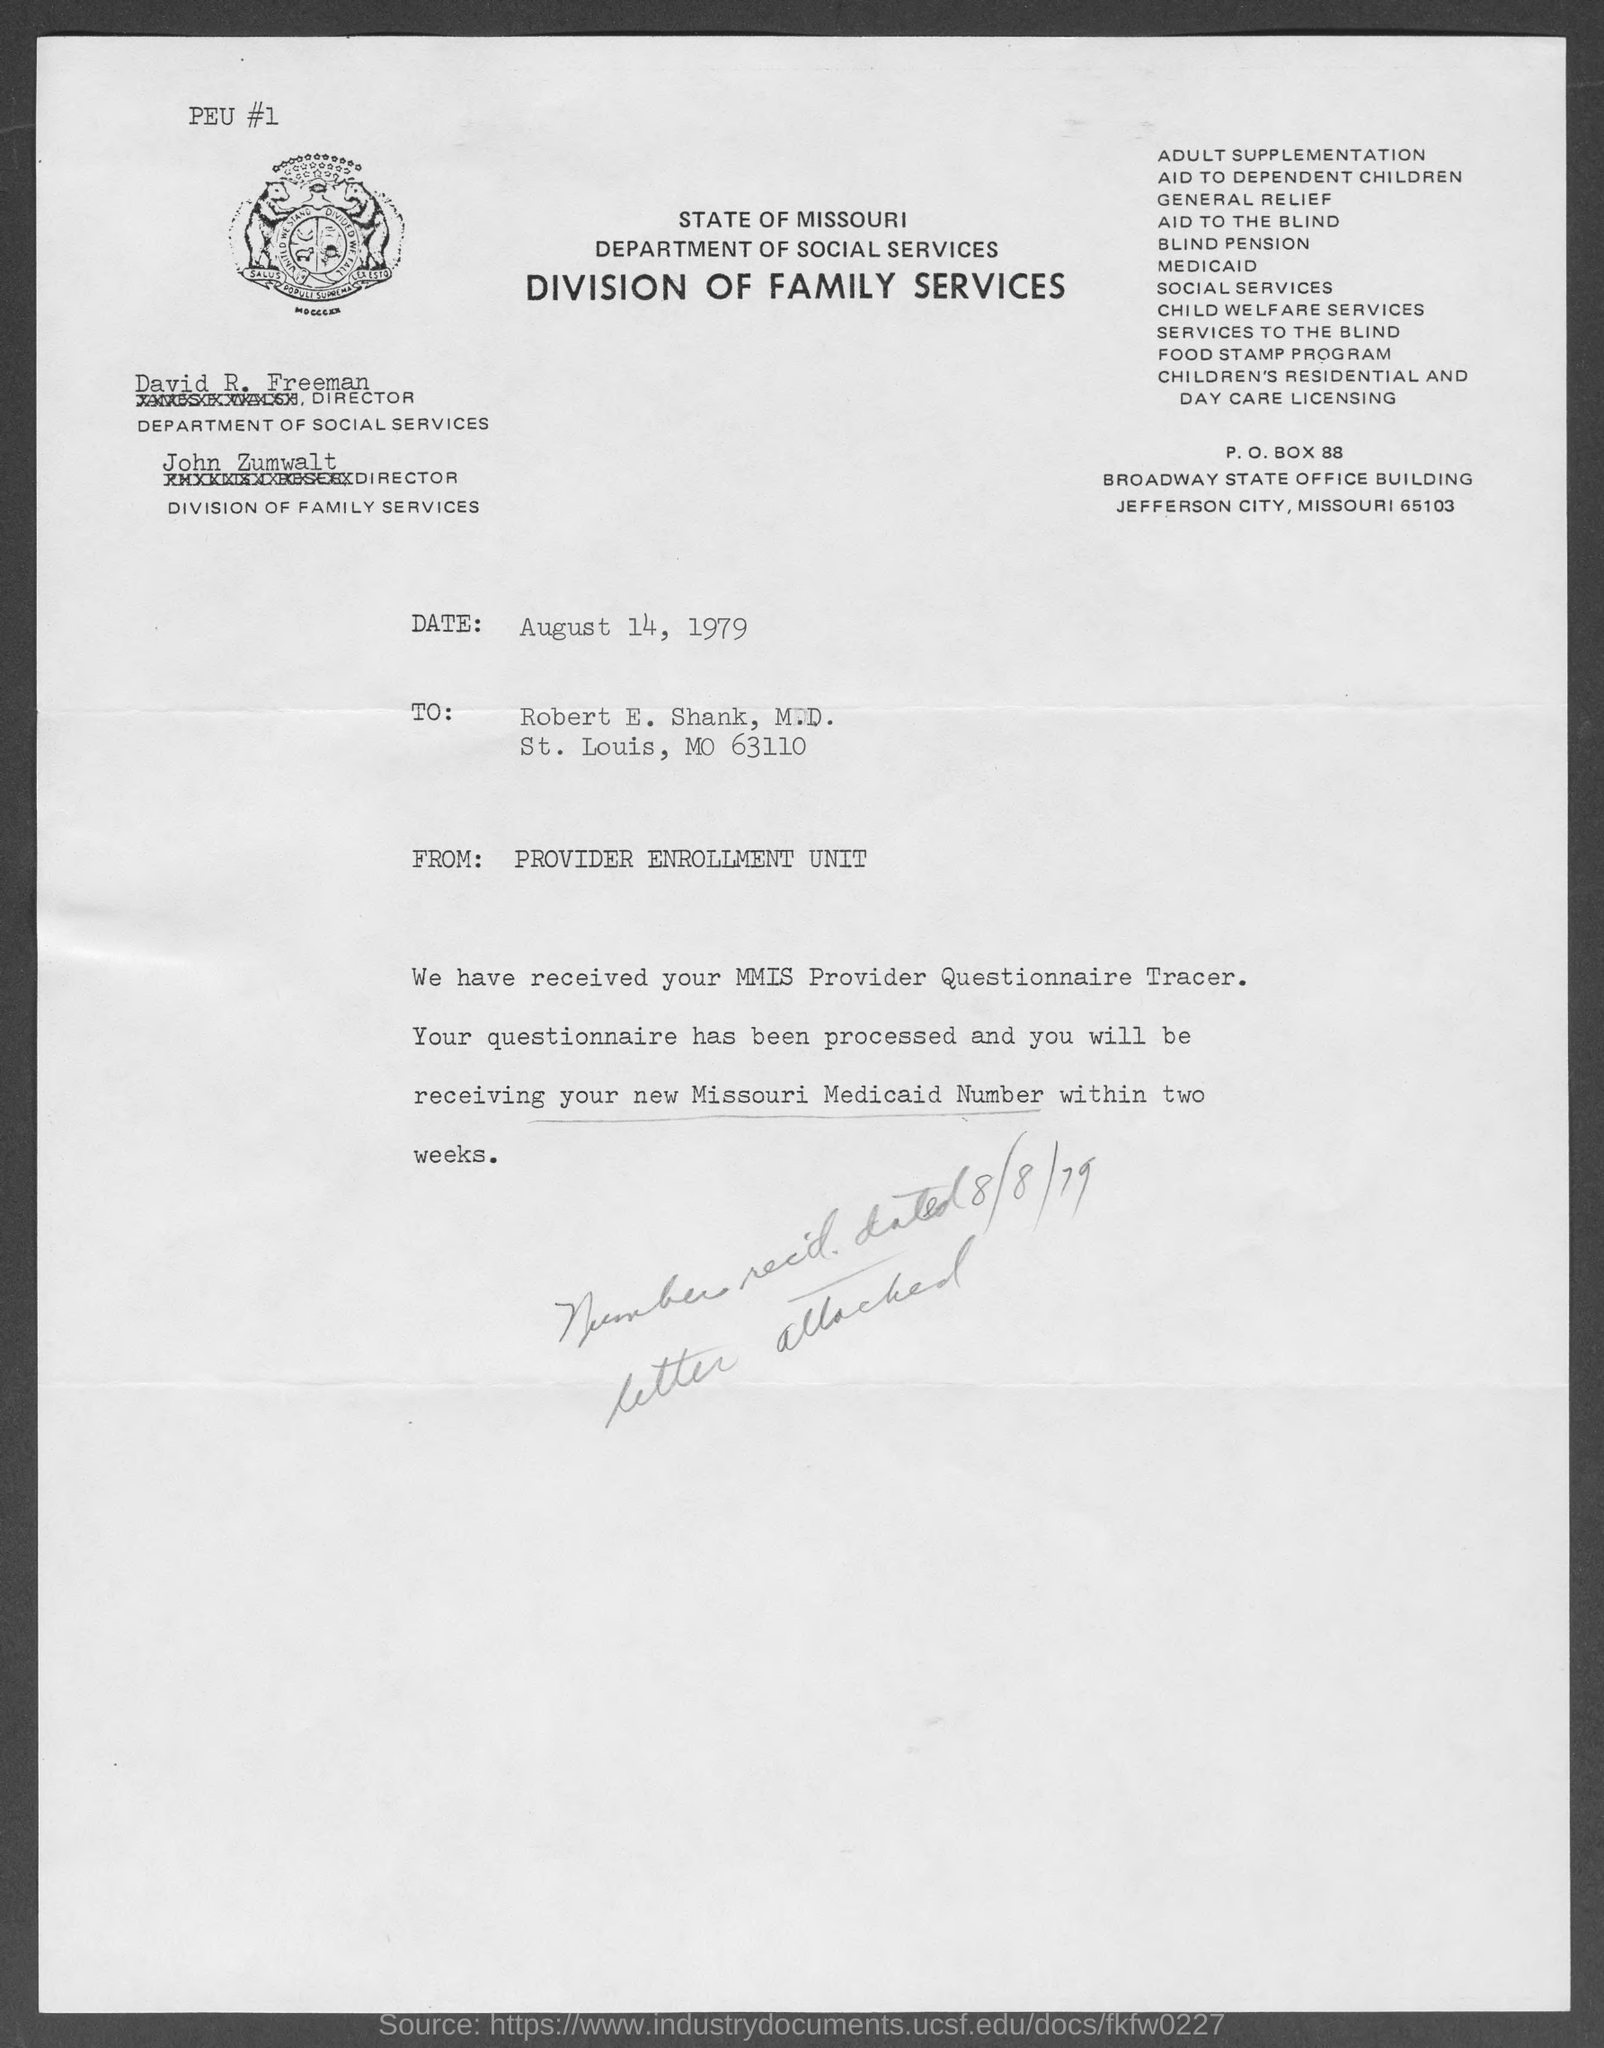What is the date in the document?
Your answer should be very brief. August 14, 1979. Who is the director of department of social services?
Your response must be concise. David R. Freeman. Who is the director of division of family services?
Your answer should be very brief. John Zumwalt. What is the p.o. box no. of state of missouri department of social services and division of family services?
Offer a very short reply. 88. 